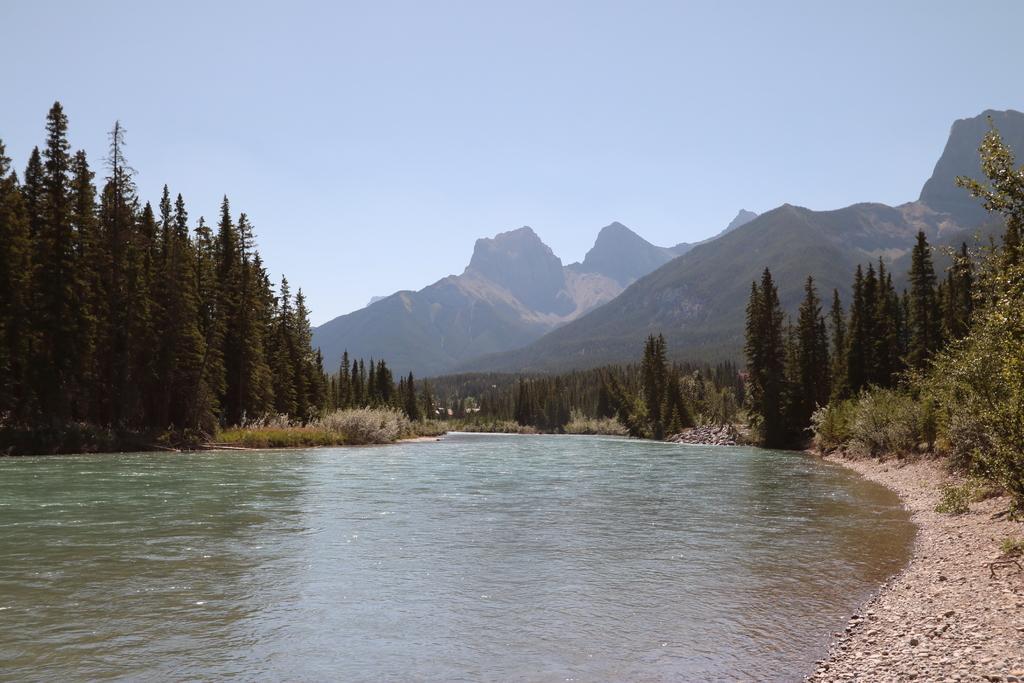Can you describe this image briefly? In this picture I can see water. There are trees, hills, and in the background there is the sky. 